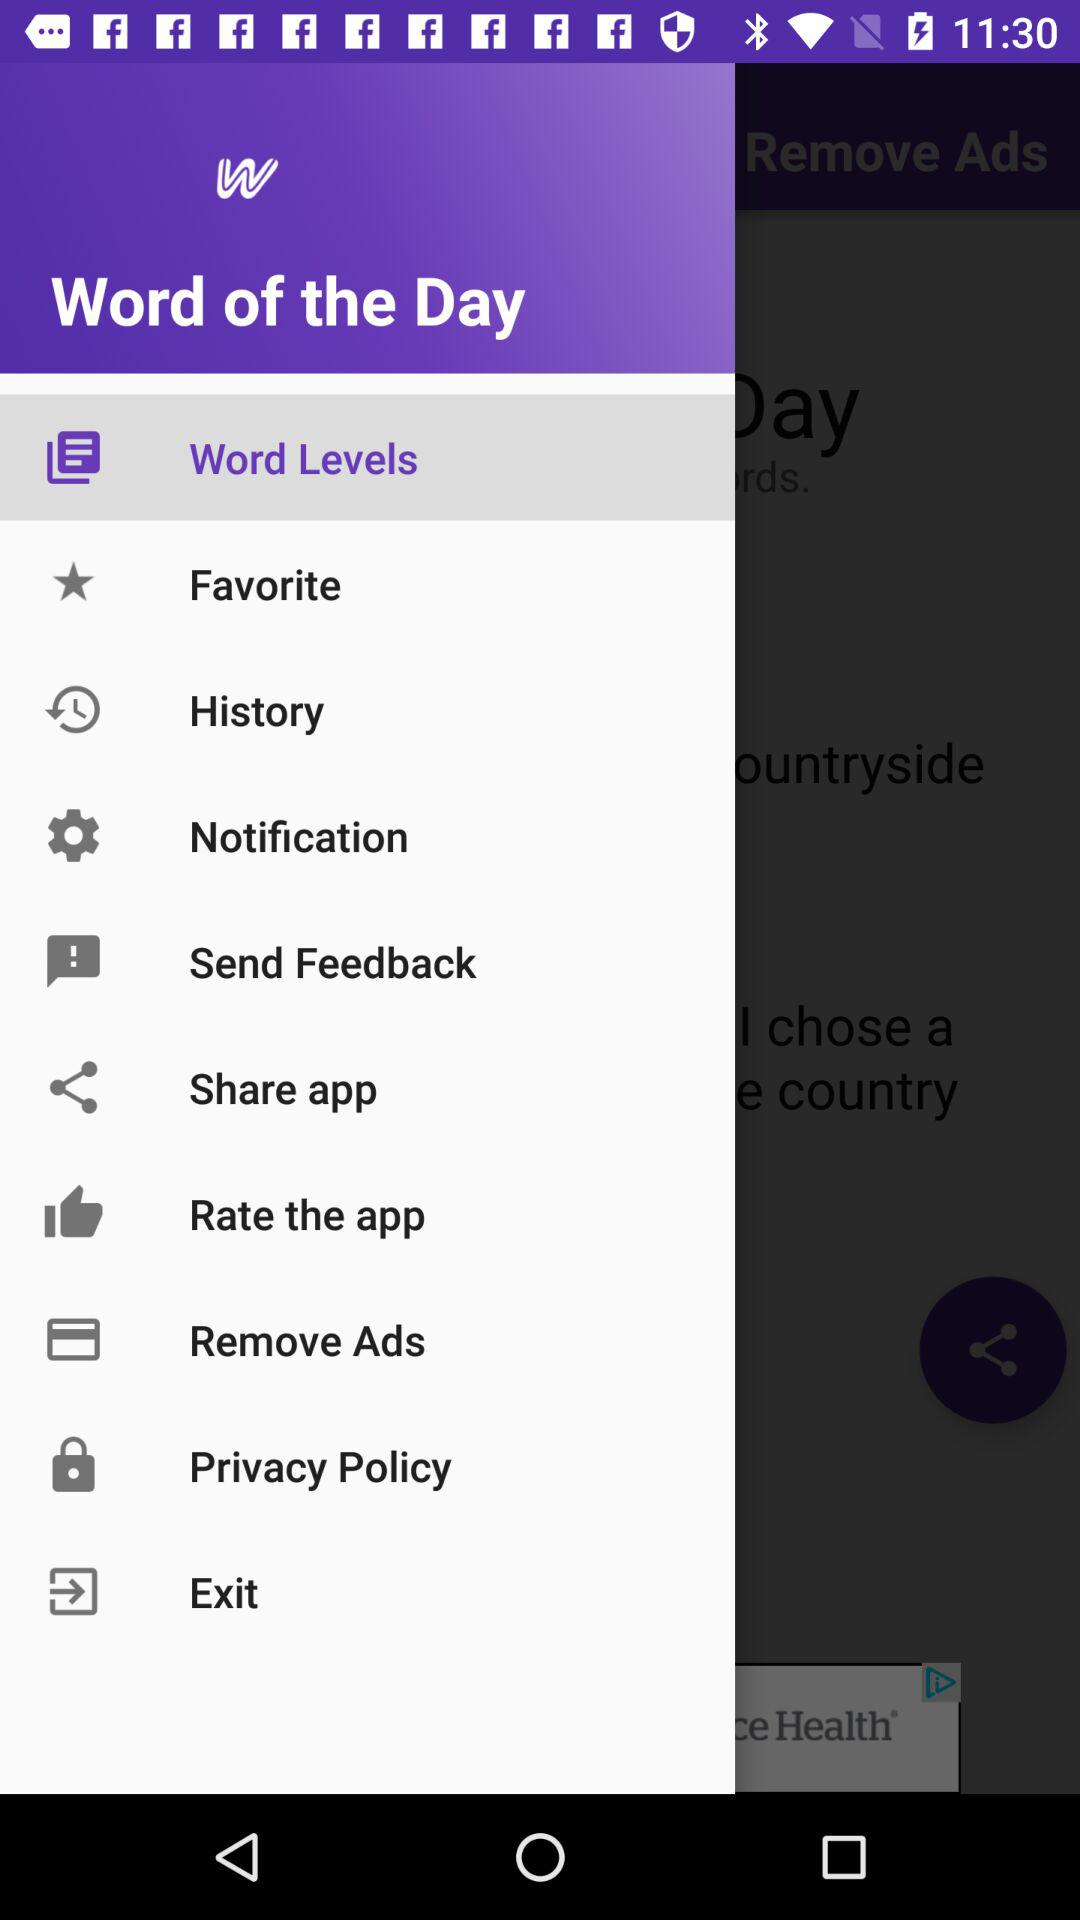Which item has been selected from the menu? The selected item is "Word Levels". 